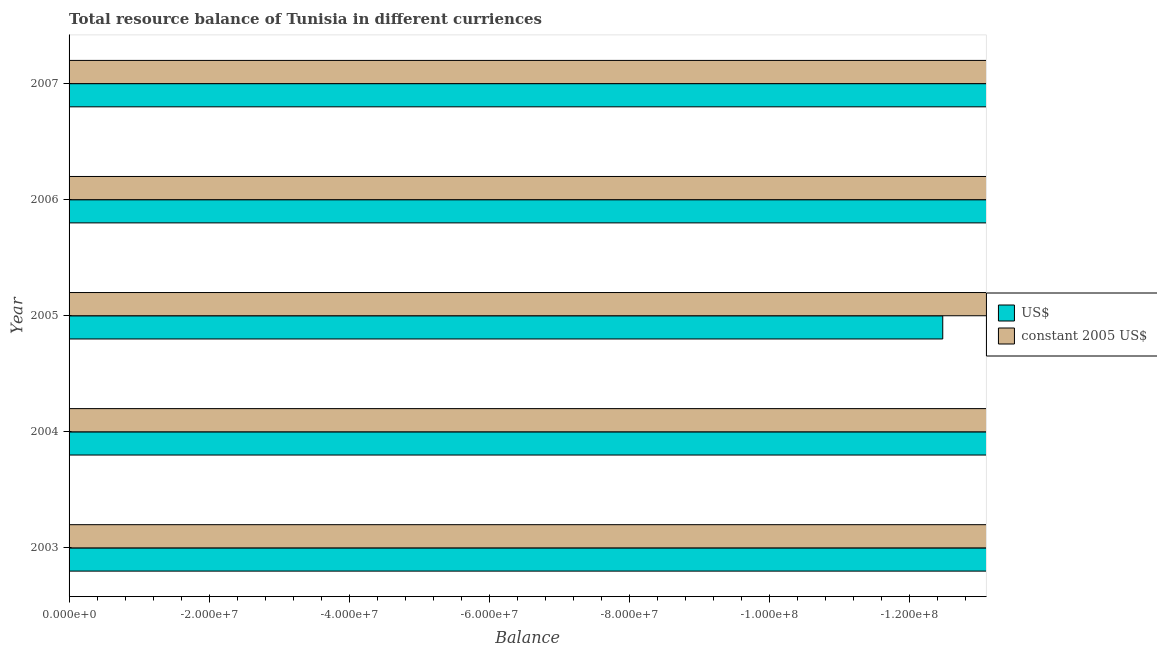How many different coloured bars are there?
Provide a short and direct response. 0. Are the number of bars per tick equal to the number of legend labels?
Your response must be concise. No. Are the number of bars on each tick of the Y-axis equal?
Ensure brevity in your answer.  Yes. What is the label of the 2nd group of bars from the top?
Provide a succinct answer. 2006. In how many years, is the resource balance in constant us$ greater than -84000000 units?
Give a very brief answer. 0. In how many years, is the resource balance in us$ greater than the average resource balance in us$ taken over all years?
Provide a succinct answer. 0. How many bars are there?
Offer a terse response. 0. Are all the bars in the graph horizontal?
Offer a very short reply. Yes. How many years are there in the graph?
Keep it short and to the point. 5. Are the values on the major ticks of X-axis written in scientific E-notation?
Provide a succinct answer. Yes. Does the graph contain grids?
Offer a terse response. No. How are the legend labels stacked?
Make the answer very short. Vertical. What is the title of the graph?
Ensure brevity in your answer.  Total resource balance of Tunisia in different curriences. What is the label or title of the X-axis?
Your response must be concise. Balance. What is the label or title of the Y-axis?
Your response must be concise. Year. What is the Balance of US$ in 2004?
Your answer should be very brief. 0. What is the Balance in constant 2005 US$ in 2004?
Offer a very short reply. 0. What is the Balance of US$ in 2005?
Provide a succinct answer. 0. What is the Balance in constant 2005 US$ in 2006?
Your answer should be compact. 0. What is the Balance in US$ in 2007?
Provide a succinct answer. 0. What is the Balance in constant 2005 US$ in 2007?
Your answer should be compact. 0. What is the average Balance in constant 2005 US$ per year?
Your answer should be very brief. 0. 